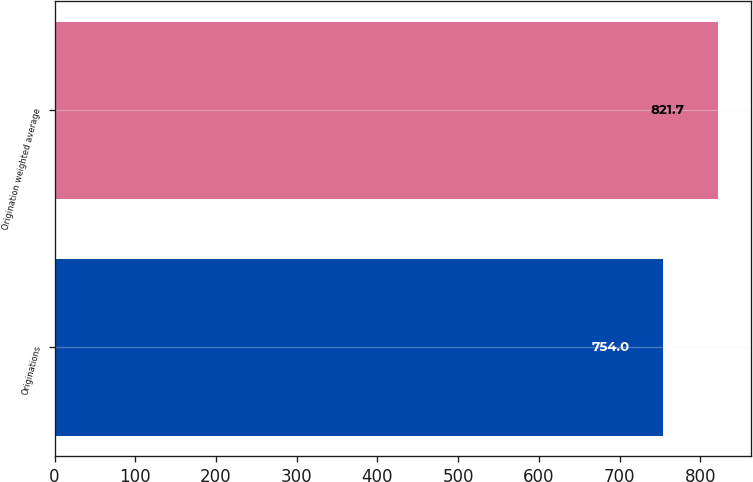Convert chart to OTSL. <chart><loc_0><loc_0><loc_500><loc_500><bar_chart><fcel>Originations<fcel>Origination weighted average<nl><fcel>754<fcel>821.7<nl></chart> 